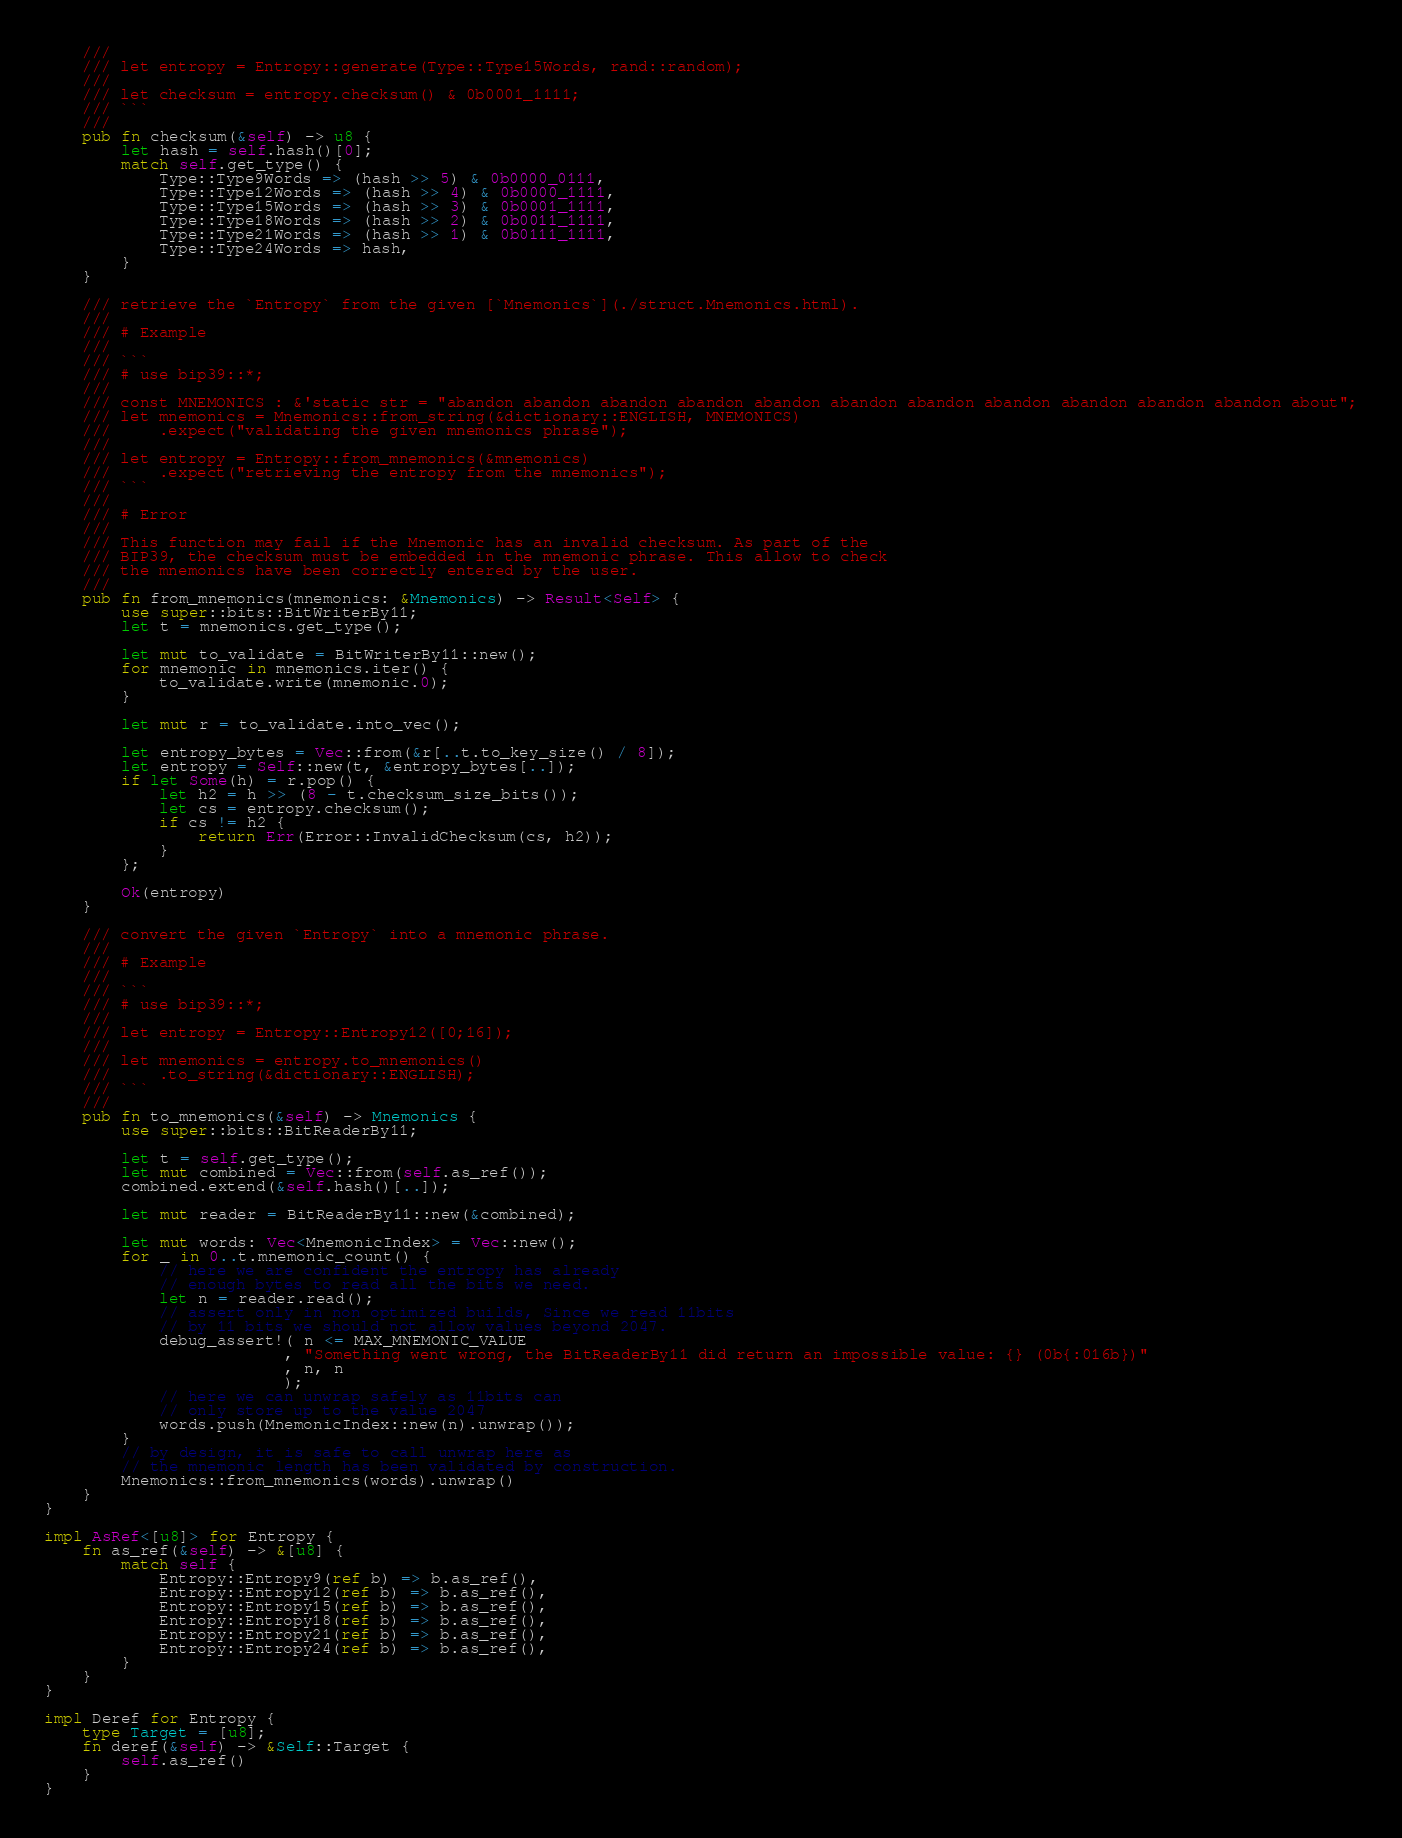Convert code to text. <code><loc_0><loc_0><loc_500><loc_500><_Rust_>    ///
    /// let entropy = Entropy::generate(Type::Type15Words, rand::random);
    ///
    /// let checksum = entropy.checksum() & 0b0001_1111;
    /// ```
    ///
    pub fn checksum(&self) -> u8 {
        let hash = self.hash()[0];
        match self.get_type() {
            Type::Type9Words => (hash >> 5) & 0b0000_0111,
            Type::Type12Words => (hash >> 4) & 0b0000_1111,
            Type::Type15Words => (hash >> 3) & 0b0001_1111,
            Type::Type18Words => (hash >> 2) & 0b0011_1111,
            Type::Type21Words => (hash >> 1) & 0b0111_1111,
            Type::Type24Words => hash,
        }
    }

    /// retrieve the `Entropy` from the given [`Mnemonics`](./struct.Mnemonics.html).
    ///
    /// # Example
    ///
    /// ```
    /// # use bip39::*;
    ///
    /// const MNEMONICS : &'static str = "abandon abandon abandon abandon abandon abandon abandon abandon abandon abandon abandon about";
    /// let mnemonics = Mnemonics::from_string(&dictionary::ENGLISH, MNEMONICS)
    ///     .expect("validating the given mnemonics phrase");
    ///
    /// let entropy = Entropy::from_mnemonics(&mnemonics)
    ///     .expect("retrieving the entropy from the mnemonics");
    /// ```
    ///
    /// # Error
    ///
    /// This function may fail if the Mnemonic has an invalid checksum. As part of the
    /// BIP39, the checksum must be embedded in the mnemonic phrase. This allow to check
    /// the mnemonics have been correctly entered by the user.
    ///
    pub fn from_mnemonics(mnemonics: &Mnemonics) -> Result<Self> {
        use super::bits::BitWriterBy11;
        let t = mnemonics.get_type();

        let mut to_validate = BitWriterBy11::new();
        for mnemonic in mnemonics.iter() {
            to_validate.write(mnemonic.0);
        }

        let mut r = to_validate.into_vec();

        let entropy_bytes = Vec::from(&r[..t.to_key_size() / 8]);
        let entropy = Self::new(t, &entropy_bytes[..]);
        if let Some(h) = r.pop() {
            let h2 = h >> (8 - t.checksum_size_bits());
            let cs = entropy.checksum();
            if cs != h2 {
                return Err(Error::InvalidChecksum(cs, h2));
            }
        };

        Ok(entropy)
    }

    /// convert the given `Entropy` into a mnemonic phrase.
    ///
    /// # Example
    ///
    /// ```
    /// # use bip39::*;
    ///
    /// let entropy = Entropy::Entropy12([0;16]);
    ///
    /// let mnemonics = entropy.to_mnemonics()
    ///     .to_string(&dictionary::ENGLISH);
    /// ```
    ///
    pub fn to_mnemonics(&self) -> Mnemonics {
        use super::bits::BitReaderBy11;

        let t = self.get_type();
        let mut combined = Vec::from(self.as_ref());
        combined.extend(&self.hash()[..]);

        let mut reader = BitReaderBy11::new(&combined);

        let mut words: Vec<MnemonicIndex> = Vec::new();
        for _ in 0..t.mnemonic_count() {
            // here we are confident the entropy has already
            // enough bytes to read all the bits we need.
            let n = reader.read();
            // assert only in non optimized builds, Since we read 11bits
            // by 11 bits we should not allow values beyond 2047.
            debug_assert!( n <= MAX_MNEMONIC_VALUE
                         , "Something went wrong, the BitReaderBy11 did return an impossible value: {} (0b{:016b})"
                         , n, n
                         );
            // here we can unwrap safely as 11bits can
            // only store up to the value 2047
            words.push(MnemonicIndex::new(n).unwrap());
        }
        // by design, it is safe to call unwrap here as
        // the mnemonic length has been validated by construction.
        Mnemonics::from_mnemonics(words).unwrap()
    }
}

impl AsRef<[u8]> for Entropy {
    fn as_ref(&self) -> &[u8] {
        match self {
            Entropy::Entropy9(ref b) => b.as_ref(),
            Entropy::Entropy12(ref b) => b.as_ref(),
            Entropy::Entropy15(ref b) => b.as_ref(),
            Entropy::Entropy18(ref b) => b.as_ref(),
            Entropy::Entropy21(ref b) => b.as_ref(),
            Entropy::Entropy24(ref b) => b.as_ref(),
        }
    }
}

impl Deref for Entropy {
    type Target = [u8];
    fn deref(&self) -> &Self::Target {
        self.as_ref()
    }
}
</code> 